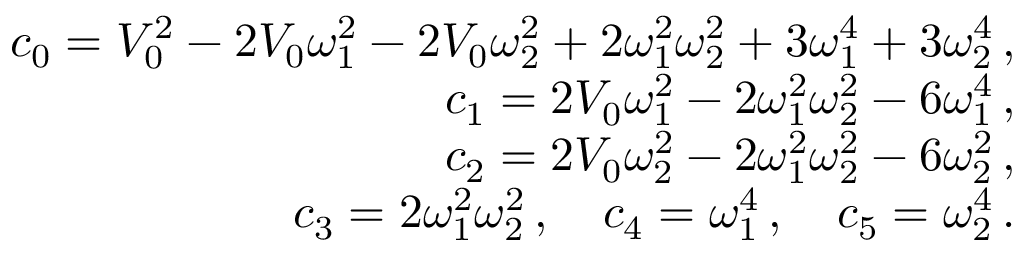<formula> <loc_0><loc_0><loc_500><loc_500>\begin{array} { r } { c _ { 0 } = V _ { 0 } ^ { 2 } - 2 V _ { 0 } \omega _ { 1 } ^ { 2 } - 2 V _ { 0 } \omega _ { 2 } ^ { 2 } + 2 \omega _ { 1 } ^ { 2 } \omega _ { 2 } ^ { 2 } + 3 \omega _ { 1 } ^ { 4 } + 3 \omega _ { 2 } ^ { 4 } \, , } \\ { c _ { 1 } = 2 V _ { 0 } \omega _ { 1 } ^ { 2 } - 2 \omega _ { 1 } ^ { 2 } \omega _ { 2 } ^ { 2 } - 6 \omega _ { 1 } ^ { 4 } \, , } \\ { c _ { 2 } = 2 V _ { 0 } \omega _ { 2 } ^ { 2 } - 2 \omega _ { 1 } ^ { 2 } \omega _ { 2 } ^ { 2 } - 6 \omega _ { 2 } ^ { 2 } \, , } \\ { c _ { 3 } = 2 \omega _ { 1 } ^ { 2 } \omega _ { 2 } ^ { 2 } \, , \quad c _ { 4 } = \omega _ { 1 } ^ { 4 } \, , \quad c _ { 5 } = \omega _ { 2 } ^ { 4 } \, . } \end{array}</formula> 